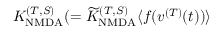Convert formula to latex. <formula><loc_0><loc_0><loc_500><loc_500>K _ { N M D A } ^ { ( T , S ) } ( = { \widetilde { K } } _ { N M D A } ^ { ( T , S ) } \langle f ( v ^ { ( T ) } ( t ) ) \rangle</formula> 